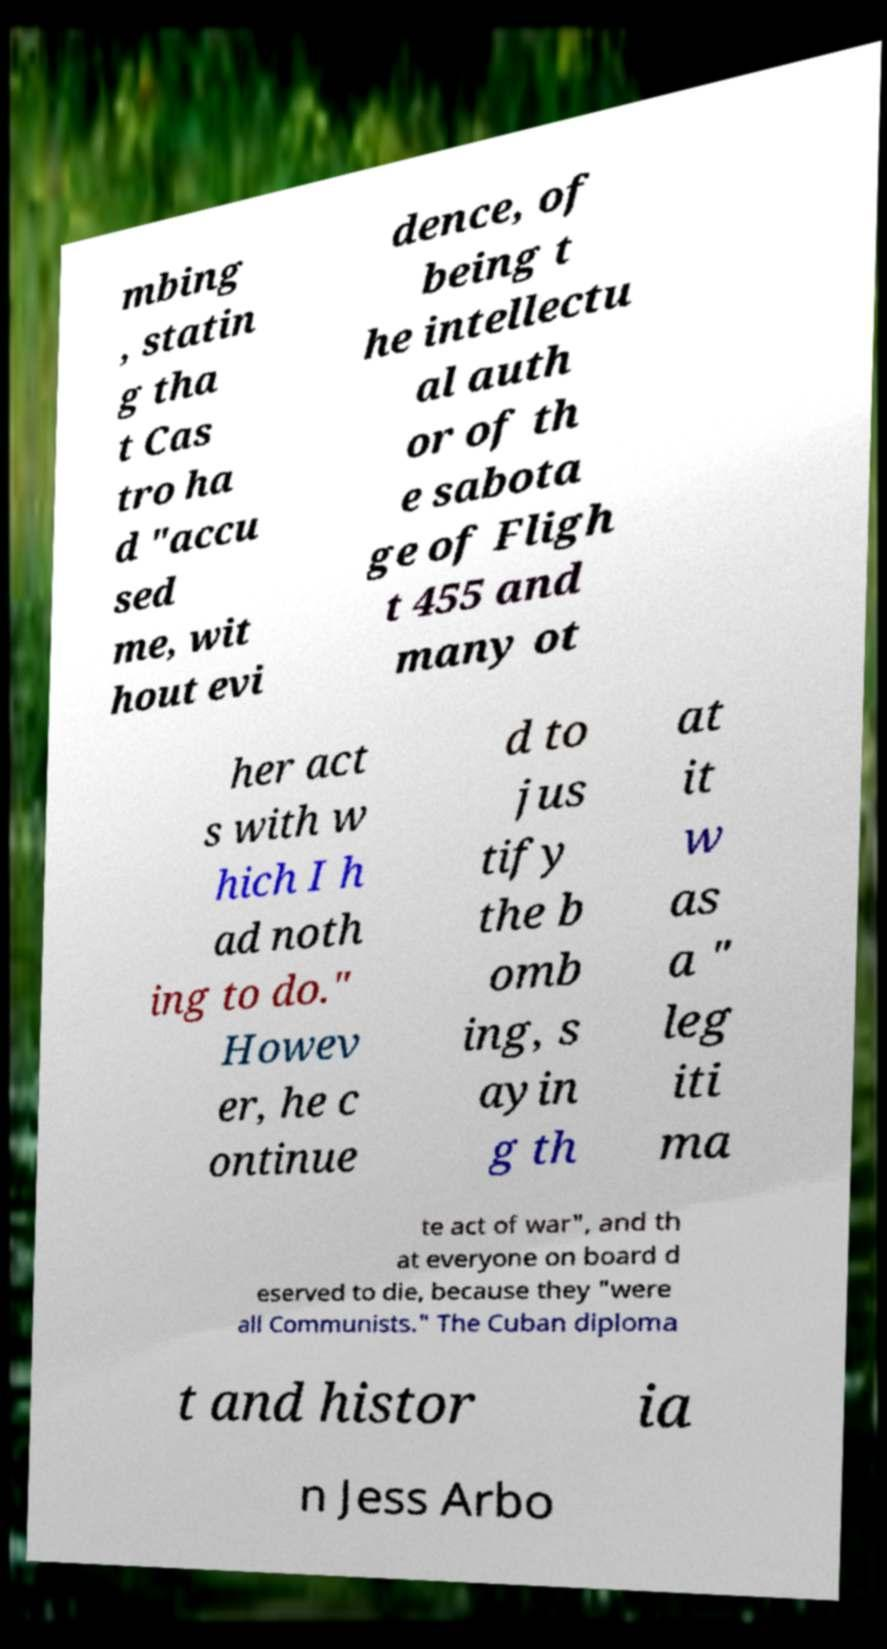I need the written content from this picture converted into text. Can you do that? mbing , statin g tha t Cas tro ha d "accu sed me, wit hout evi dence, of being t he intellectu al auth or of th e sabota ge of Fligh t 455 and many ot her act s with w hich I h ad noth ing to do." Howev er, he c ontinue d to jus tify the b omb ing, s ayin g th at it w as a " leg iti ma te act of war", and th at everyone on board d eserved to die, because they "were all Communists." The Cuban diploma t and histor ia n Jess Arbo 